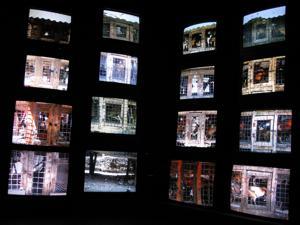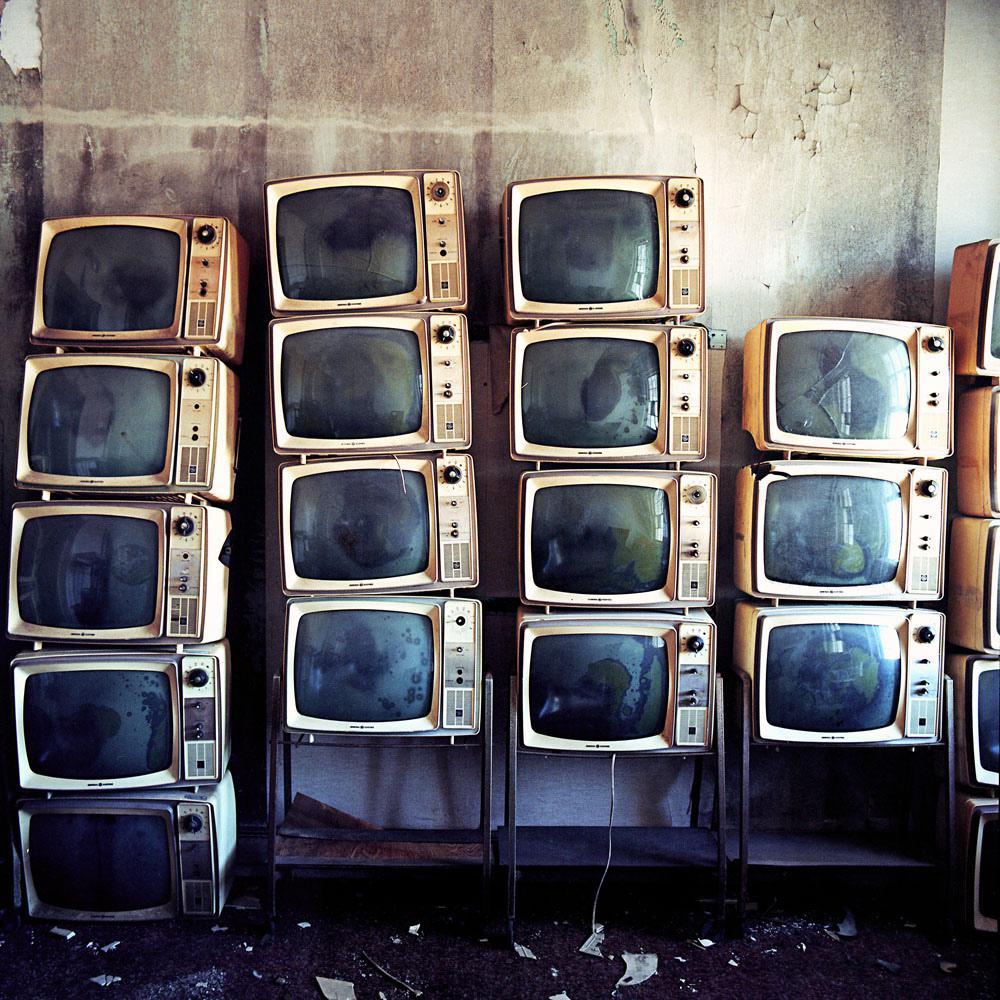The first image is the image on the left, the second image is the image on the right. Assess this claim about the two images: "One image shows an interior with an exposed beam ceiling and multiple stacks of televisions with pictures on their screens stacked along the lefthand wall.". Correct or not? Answer yes or no. No. The first image is the image on the left, the second image is the image on the right. Evaluate the accuracy of this statement regarding the images: "There are at least three televisions turned off.". Is it true? Answer yes or no. Yes. 